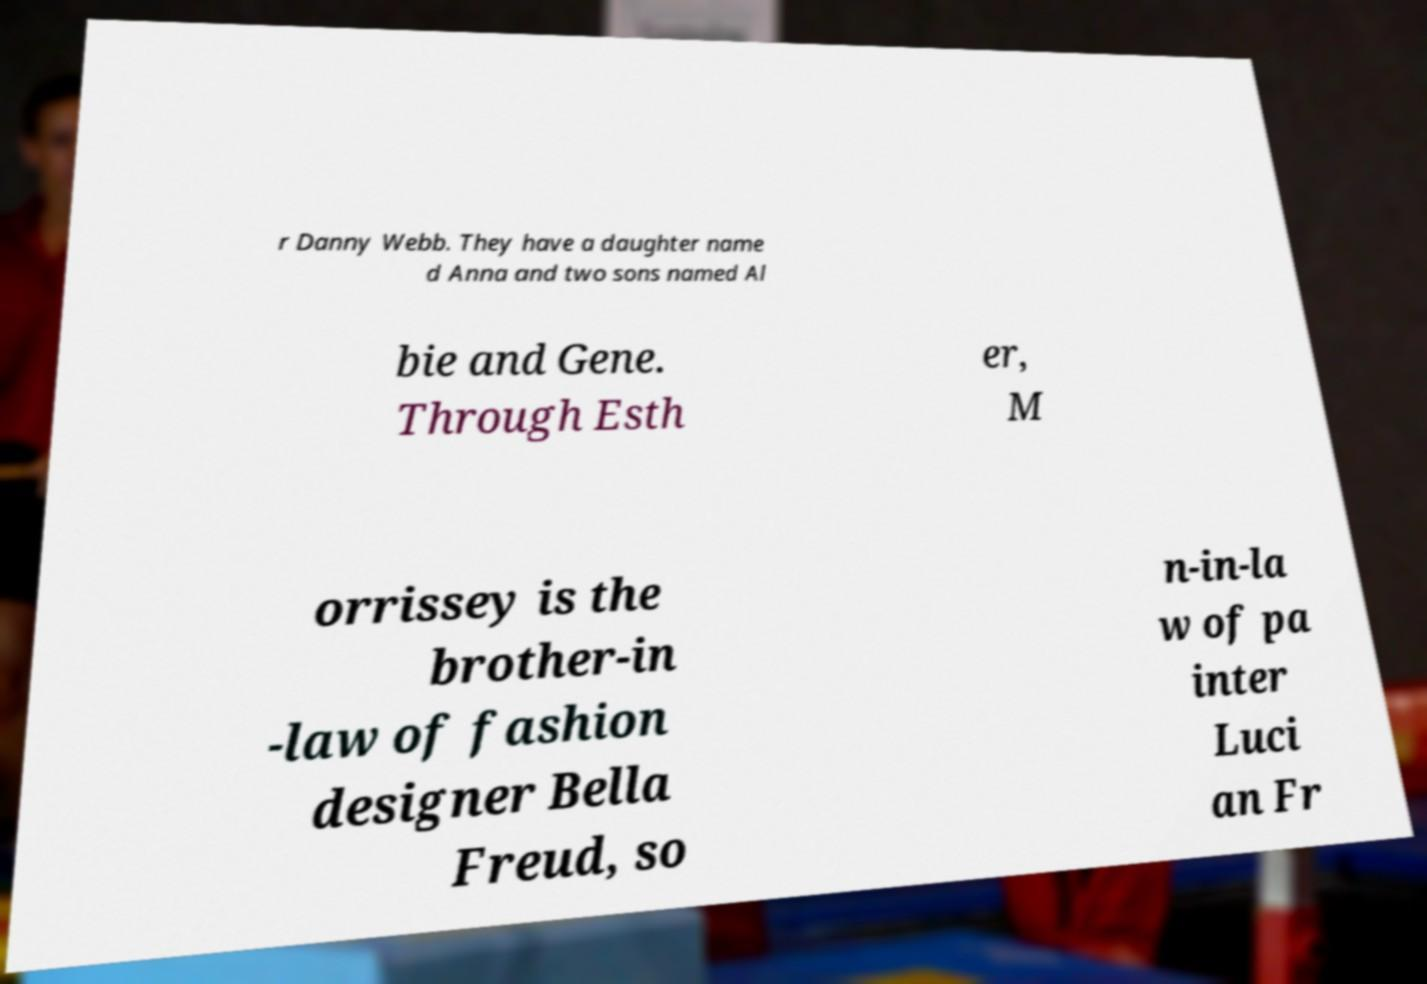Please read and relay the text visible in this image. What does it say? r Danny Webb. They have a daughter name d Anna and two sons named Al bie and Gene. Through Esth er, M orrissey is the brother-in -law of fashion designer Bella Freud, so n-in-la w of pa inter Luci an Fr 